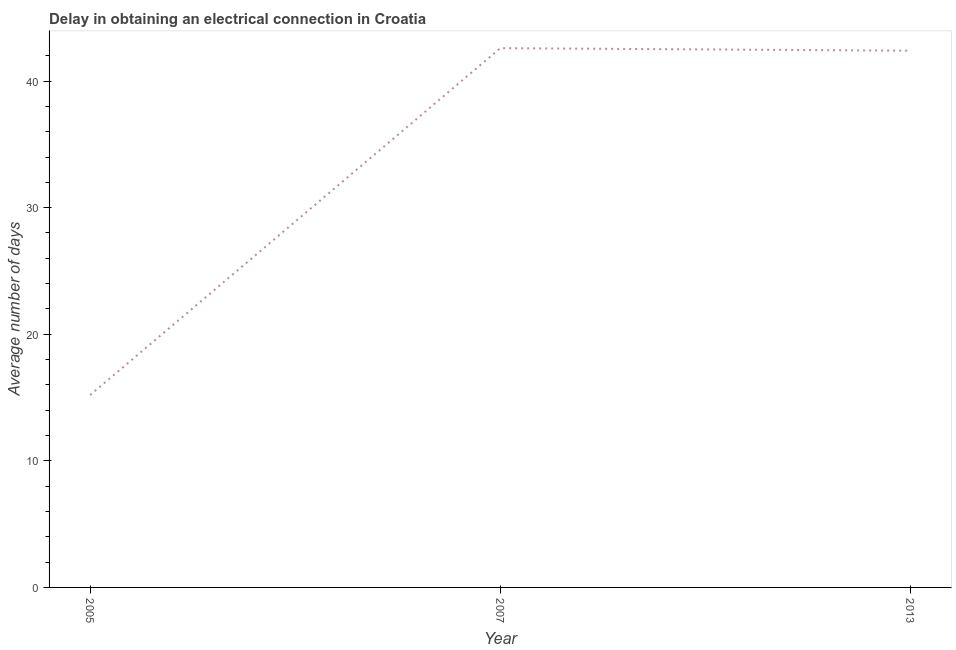What is the dalay in electrical connection in 2007?
Give a very brief answer. 42.6. Across all years, what is the maximum dalay in electrical connection?
Ensure brevity in your answer.  42.6. Across all years, what is the minimum dalay in electrical connection?
Your response must be concise. 15.2. In which year was the dalay in electrical connection maximum?
Your answer should be very brief. 2007. In which year was the dalay in electrical connection minimum?
Make the answer very short. 2005. What is the sum of the dalay in electrical connection?
Provide a short and direct response. 100.2. What is the difference between the dalay in electrical connection in 2005 and 2013?
Your response must be concise. -27.2. What is the average dalay in electrical connection per year?
Keep it short and to the point. 33.4. What is the median dalay in electrical connection?
Provide a succinct answer. 42.4. What is the ratio of the dalay in electrical connection in 2005 to that in 2007?
Your answer should be very brief. 0.36. Is the dalay in electrical connection in 2005 less than that in 2013?
Ensure brevity in your answer.  Yes. What is the difference between the highest and the second highest dalay in electrical connection?
Your answer should be compact. 0.2. What is the difference between the highest and the lowest dalay in electrical connection?
Your response must be concise. 27.4. Does the dalay in electrical connection monotonically increase over the years?
Ensure brevity in your answer.  No. Are the values on the major ticks of Y-axis written in scientific E-notation?
Provide a short and direct response. No. Does the graph contain grids?
Ensure brevity in your answer.  No. What is the title of the graph?
Make the answer very short. Delay in obtaining an electrical connection in Croatia. What is the label or title of the X-axis?
Provide a succinct answer. Year. What is the label or title of the Y-axis?
Offer a terse response. Average number of days. What is the Average number of days in 2007?
Give a very brief answer. 42.6. What is the Average number of days of 2013?
Offer a very short reply. 42.4. What is the difference between the Average number of days in 2005 and 2007?
Your answer should be compact. -27.4. What is the difference between the Average number of days in 2005 and 2013?
Keep it short and to the point. -27.2. What is the ratio of the Average number of days in 2005 to that in 2007?
Make the answer very short. 0.36. What is the ratio of the Average number of days in 2005 to that in 2013?
Keep it short and to the point. 0.36. What is the ratio of the Average number of days in 2007 to that in 2013?
Give a very brief answer. 1. 